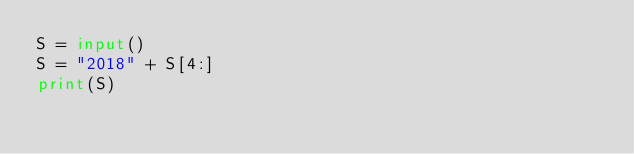Convert code to text. <code><loc_0><loc_0><loc_500><loc_500><_Python_>S = input()
S = "2018" + S[4:]
print(S)</code> 